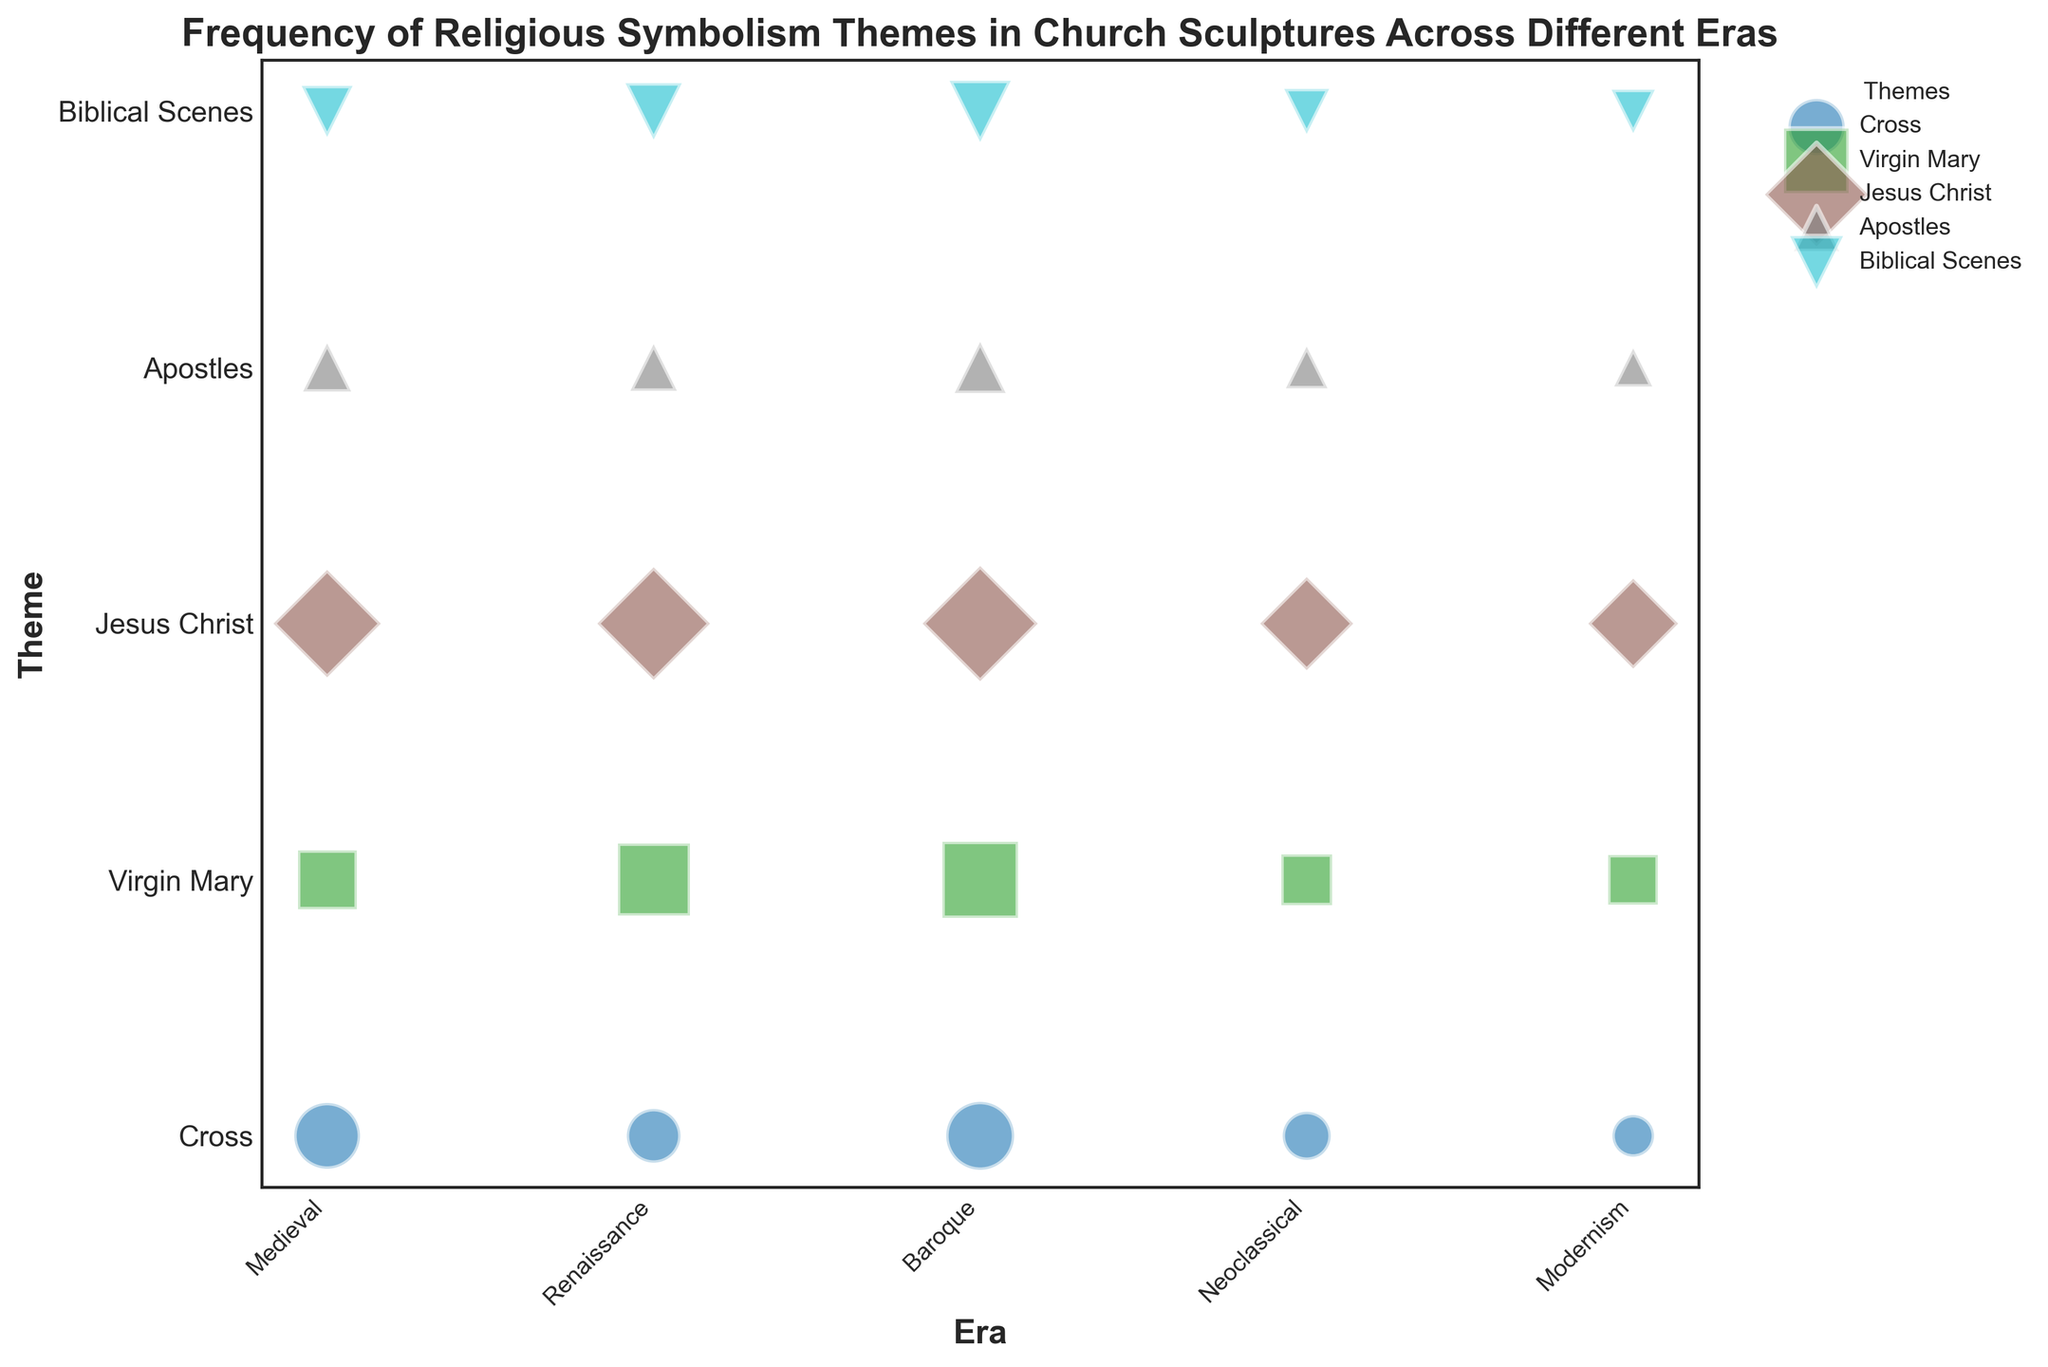What is the most frequent theme in the Baroque era? By examining the size of the plotted bubbles for the Baroque era, observe which theme has the largest bubble size. The Virgin Mary theme has the largest bubble size, indicating the highest frequency.
Answer: Virgin Mary Which era has the lowest frequency for the Cross theme, and what is that frequency? Compare the bubble sizes for the Cross theme across all eras. The smallest bubble size for the Cross theme is in the Modernism era. The frequency associated with this is 60.
Answer: Modernism, 60 How does the frequency of the Jesus Christ theme in the Renaissance era compare with the Neoclassical era? Look at the relative bubble sizes for the Jesus Christ theme in the Renaissance and Neoclassical eras. The bubble size in the Renaissance era is larger, indicating a higher frequency. The frequencies are 220 and 150, respectively.
Answer: Renaissance is higher What is the total frequency of the Apostles theme across all eras? Add the frequencies of the Apostles theme in each era: 80 (Medieval) + 75 (Renaissance) + 90 (Baroque) + 60 (Neoclassical) + 50 (Modernism). This gives the total frequency.
Answer: 355 Which theme has consistently increased in frequency from the Medieval era to the Baroque era? Observe the trends in bubble sizes for each theme from Medieval to Baroque. The Virgin Mary theme's bubble sizes increase from 120 (Medieval) to 180 (Renaissance) to 200 (Baroque), showing a consistent increase.
Answer: Virgin Mary What is the combined frequency for Biblical Scenes and Apostles in the Baroque era? Find the frequency values for Biblical Scenes and Apostles in the Baroque era and add them: 130 (Biblical Scenes) + 90 (Apostles).
Answer: 220 Which era shows the highest overall diversity in theme frequencies, and how can you tell? Look at the spread and variability in bubble sizes for each era. The Baroque era shows considerable variability with large bubble sizes for several themes, indicating a high diversity in theme frequencies.
Answer: Baroque How does the frequency of the Virgin Mary theme in the Modernism era compare to the Neoclassical era? Compare the bubble sizes for the Virgin Mary theme in the Modernism and Neoclassical eras. The bubble in the Modernism era is slightly smaller than in the Neoclassical era, with frequencies of 85 and 90, respectively.
Answer: Modernism is lower In which era is the frequency for the Jesus Christ theme the highest, and what is that frequency? Examine the largest bubble for the Jesus Christ theme across all eras. The highest bubble size is in the Baroque era, with a frequency of 230.
Answer: Baroque, 230 